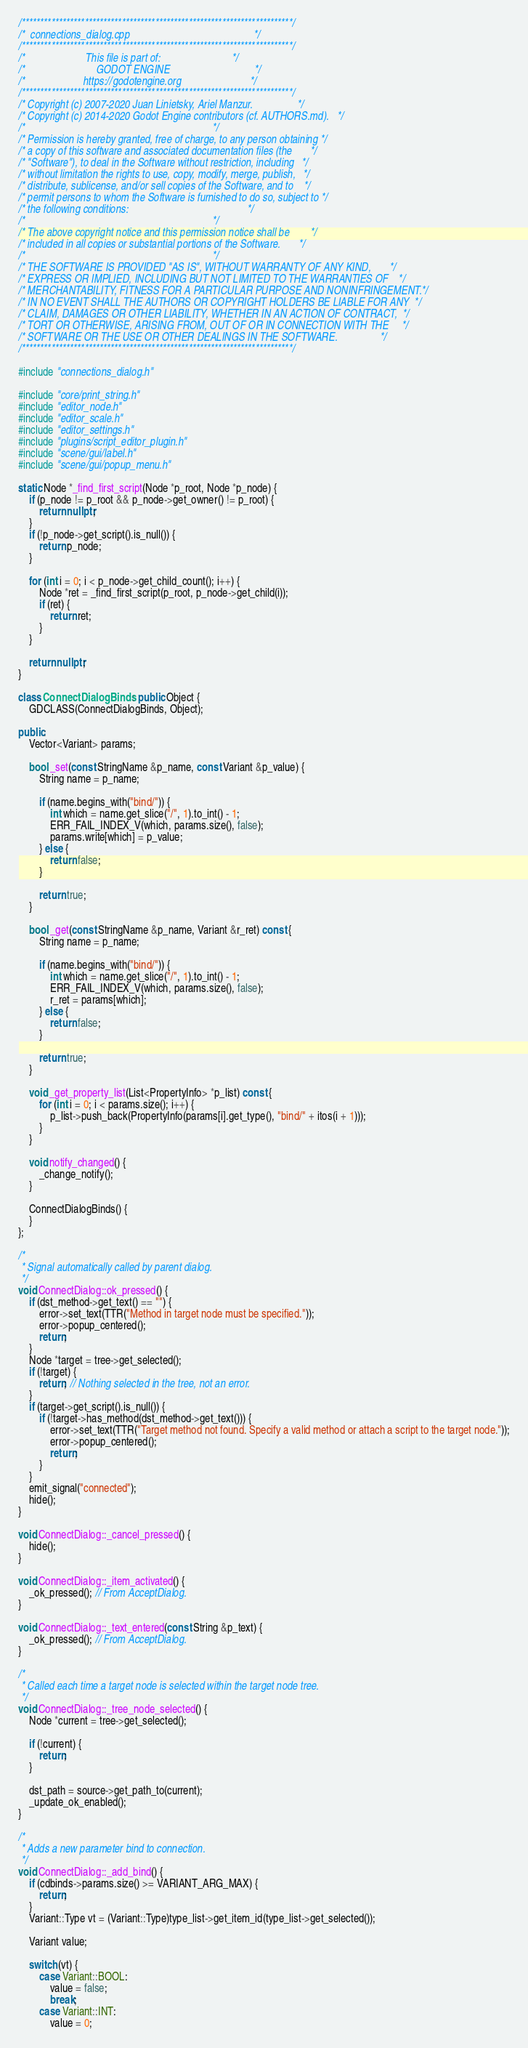<code> <loc_0><loc_0><loc_500><loc_500><_C++_>/*************************************************************************/
/*  connections_dialog.cpp                                               */
/*************************************************************************/
/*                       This file is part of:                           */
/*                           GODOT ENGINE                                */
/*                      https://godotengine.org                          */
/*************************************************************************/
/* Copyright (c) 2007-2020 Juan Linietsky, Ariel Manzur.                 */
/* Copyright (c) 2014-2020 Godot Engine contributors (cf. AUTHORS.md).   */
/*                                                                       */
/* Permission is hereby granted, free of charge, to any person obtaining */
/* a copy of this software and associated documentation files (the       */
/* "Software"), to deal in the Software without restriction, including   */
/* without limitation the rights to use, copy, modify, merge, publish,   */
/* distribute, sublicense, and/or sell copies of the Software, and to    */
/* permit persons to whom the Software is furnished to do so, subject to */
/* the following conditions:                                             */
/*                                                                       */
/* The above copyright notice and this permission notice shall be        */
/* included in all copies or substantial portions of the Software.       */
/*                                                                       */
/* THE SOFTWARE IS PROVIDED "AS IS", WITHOUT WARRANTY OF ANY KIND,       */
/* EXPRESS OR IMPLIED, INCLUDING BUT NOT LIMITED TO THE WARRANTIES OF    */
/* MERCHANTABILITY, FITNESS FOR A PARTICULAR PURPOSE AND NONINFRINGEMENT.*/
/* IN NO EVENT SHALL THE AUTHORS OR COPYRIGHT HOLDERS BE LIABLE FOR ANY  */
/* CLAIM, DAMAGES OR OTHER LIABILITY, WHETHER IN AN ACTION OF CONTRACT,  */
/* TORT OR OTHERWISE, ARISING FROM, OUT OF OR IN CONNECTION WITH THE     */
/* SOFTWARE OR THE USE OR OTHER DEALINGS IN THE SOFTWARE.                */
/*************************************************************************/

#include "connections_dialog.h"

#include "core/print_string.h"
#include "editor_node.h"
#include "editor_scale.h"
#include "editor_settings.h"
#include "plugins/script_editor_plugin.h"
#include "scene/gui/label.h"
#include "scene/gui/popup_menu.h"

static Node *_find_first_script(Node *p_root, Node *p_node) {
	if (p_node != p_root && p_node->get_owner() != p_root) {
		return nullptr;
	}
	if (!p_node->get_script().is_null()) {
		return p_node;
	}

	for (int i = 0; i < p_node->get_child_count(); i++) {
		Node *ret = _find_first_script(p_root, p_node->get_child(i));
		if (ret) {
			return ret;
		}
	}

	return nullptr;
}

class ConnectDialogBinds : public Object {
	GDCLASS(ConnectDialogBinds, Object);

public:
	Vector<Variant> params;

	bool _set(const StringName &p_name, const Variant &p_value) {
		String name = p_name;

		if (name.begins_with("bind/")) {
			int which = name.get_slice("/", 1).to_int() - 1;
			ERR_FAIL_INDEX_V(which, params.size(), false);
			params.write[which] = p_value;
		} else {
			return false;
		}

		return true;
	}

	bool _get(const StringName &p_name, Variant &r_ret) const {
		String name = p_name;

		if (name.begins_with("bind/")) {
			int which = name.get_slice("/", 1).to_int() - 1;
			ERR_FAIL_INDEX_V(which, params.size(), false);
			r_ret = params[which];
		} else {
			return false;
		}

		return true;
	}

	void _get_property_list(List<PropertyInfo> *p_list) const {
		for (int i = 0; i < params.size(); i++) {
			p_list->push_back(PropertyInfo(params[i].get_type(), "bind/" + itos(i + 1)));
		}
	}

	void notify_changed() {
		_change_notify();
	}

	ConnectDialogBinds() {
	}
};

/*
 * Signal automatically called by parent dialog.
 */
void ConnectDialog::ok_pressed() {
	if (dst_method->get_text() == "") {
		error->set_text(TTR("Method in target node must be specified."));
		error->popup_centered();
		return;
	}
	Node *target = tree->get_selected();
	if (!target) {
		return; // Nothing selected in the tree, not an error.
	}
	if (target->get_script().is_null()) {
		if (!target->has_method(dst_method->get_text())) {
			error->set_text(TTR("Target method not found. Specify a valid method or attach a script to the target node."));
			error->popup_centered();
			return;
		}
	}
	emit_signal("connected");
	hide();
}

void ConnectDialog::_cancel_pressed() {
	hide();
}

void ConnectDialog::_item_activated() {
	_ok_pressed(); // From AcceptDialog.
}

void ConnectDialog::_text_entered(const String &p_text) {
	_ok_pressed(); // From AcceptDialog.
}

/*
 * Called each time a target node is selected within the target node tree.
 */
void ConnectDialog::_tree_node_selected() {
	Node *current = tree->get_selected();

	if (!current) {
		return;
	}

	dst_path = source->get_path_to(current);
	_update_ok_enabled();
}

/*
 * Adds a new parameter bind to connection.
 */
void ConnectDialog::_add_bind() {
	if (cdbinds->params.size() >= VARIANT_ARG_MAX) {
		return;
	}
	Variant::Type vt = (Variant::Type)type_list->get_item_id(type_list->get_selected());

	Variant value;

	switch (vt) {
		case Variant::BOOL:
			value = false;
			break;
		case Variant::INT:
			value = 0;</code> 